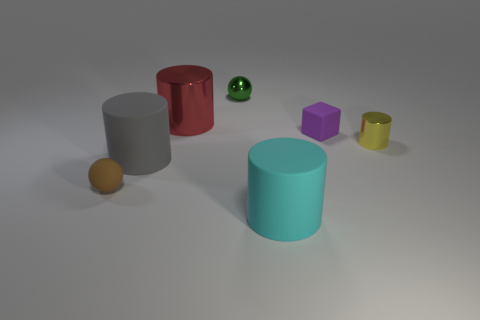What number of things are either tiny red metal balls or cylinders in front of the big gray cylinder?
Offer a terse response. 1. What material is the tiny purple thing?
Your answer should be compact. Rubber. There is a small yellow thing that is the same shape as the big gray rubber object; what is its material?
Offer a very short reply. Metal. The big matte cylinder that is right of the ball to the right of the brown object is what color?
Offer a terse response. Cyan. How many metal objects are green things or small cubes?
Provide a succinct answer. 1. Do the small purple cube and the big red cylinder have the same material?
Keep it short and to the point. No. What material is the cylinder left of the metal cylinder that is on the left side of the block made of?
Ensure brevity in your answer.  Rubber. How many tiny things are either red shiny cylinders or metallic spheres?
Offer a terse response. 1. The green sphere has what size?
Offer a very short reply. Small. Are there more large matte things right of the small cube than small yellow shiny objects?
Provide a succinct answer. No. 